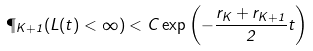<formula> <loc_0><loc_0><loc_500><loc_500>\P _ { K + 1 } ( L ( t ) < \infty ) < C \exp { \left ( - \frac { r _ { K } + r _ { K + 1 } } { 2 } t \right ) }</formula> 